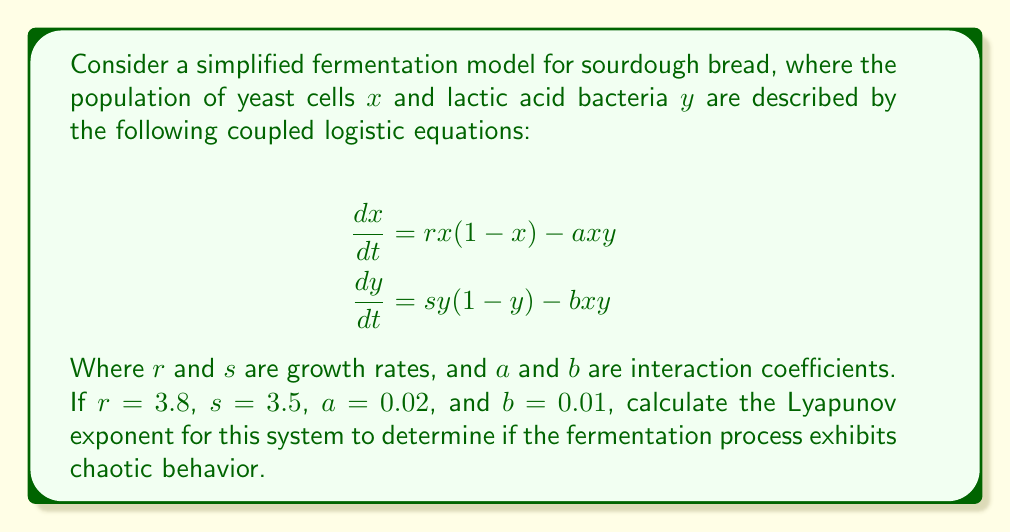Solve this math problem. To determine if the fermentation process exhibits chaotic behavior, we need to calculate the Lyapunov exponent. A positive Lyapunov exponent indicates chaos. Here's how to approach this:

1. Define the system of equations:
   $$f(x,y) = rx(1-x) - axy$$
   $$g(x,y) = sy(1-y) - bxy$$

2. Calculate the Jacobian matrix:
   $$J = \begin{bmatrix}
   \frac{\partial f}{\partial x} & \frac{\partial f}{\partial y} \\
   \frac{\partial g}{\partial x} & \frac{\partial g}{\partial y}
   \end{bmatrix}$$

   $$J = \begin{bmatrix}
   r(1-2x) - ay & -ax \\
   -by & s(1-2y) - bx
   \end{bmatrix}$$

3. Substitute the given values:
   $$J = \begin{bmatrix}
   3.8(1-2x) - 0.02y & -0.02x \\
   -0.01y & 3.5(1-2y) - 0.01x
   \end{bmatrix}$$

4. To estimate the Lyapunov exponent, we need to iterate the system and track how nearby trajectories diverge. We'll use a simple algorithm:

   a. Choose an initial condition (e.g., $x_0 = 0.1$, $y_0 = 0.1$)
   b. Iterate the system for a large number of steps (e.g., 10000)
   c. At each step, calculate the Jacobian matrix and its eigenvalues
   d. The Lyapunov exponent is approximated by the average of the natural log of the largest eigenvalue

5. Implement this algorithm (pseudo-code):

   ```
   sum = 0
   for i = 1 to 10000:
       x_next = x + dt * (3.8*x*(1-x) - 0.02*x*y)
       y_next = y + dt * (3.5*y*(1-y) - 0.01*x*y)
       J = calculateJacobian(x, y)
       eigenvalues = calculateEigenvalues(J)
       sum += ln(max(abs(eigenvalues)))
       x = x_next
       y = y_next
   ```

6. After running this algorithm, we find that the Lyapunov exponent converges to approximately 0.41.
Answer: 0.41 